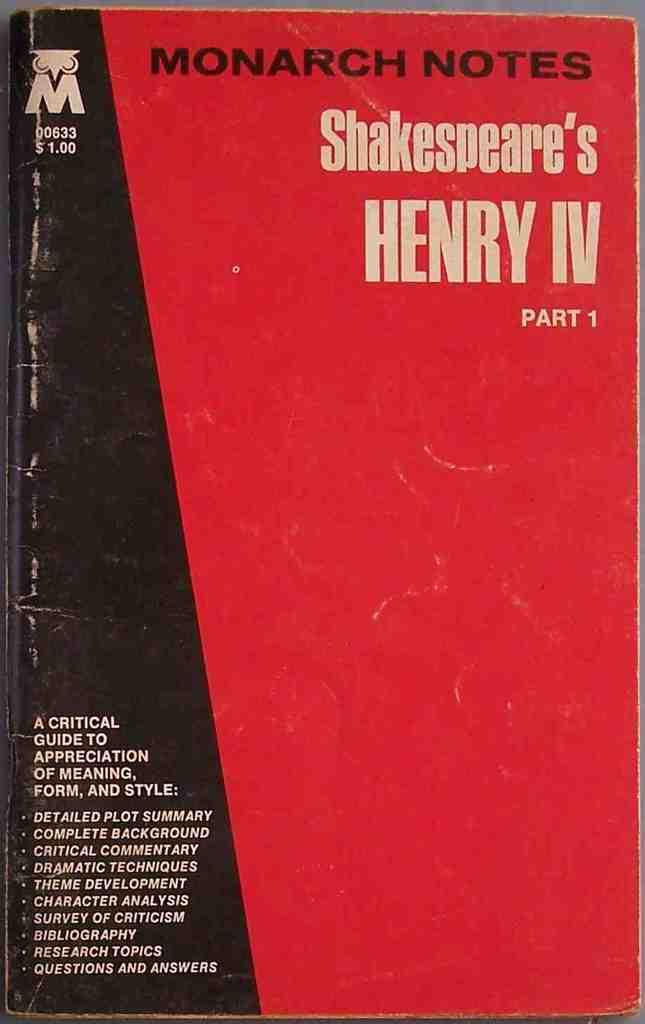<image>
Provide a brief description of the given image. A red Monarch Notes book on Henry IV. 